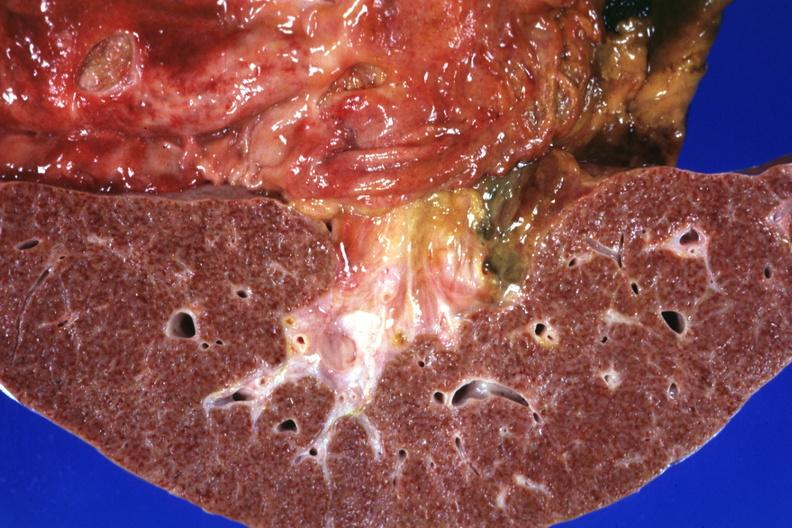does this frontal section micronodular photo show gastric and duodenal ulcers?
Answer the question using a single word or phrase. Yes 